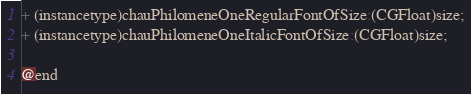Convert code to text. <code><loc_0><loc_0><loc_500><loc_500><_C_>
+ (instancetype)chauPhilomeneOneRegularFontOfSize:(CGFloat)size;
+ (instancetype)chauPhilomeneOneItalicFontOfSize:(CGFloat)size;

@end

</code> 